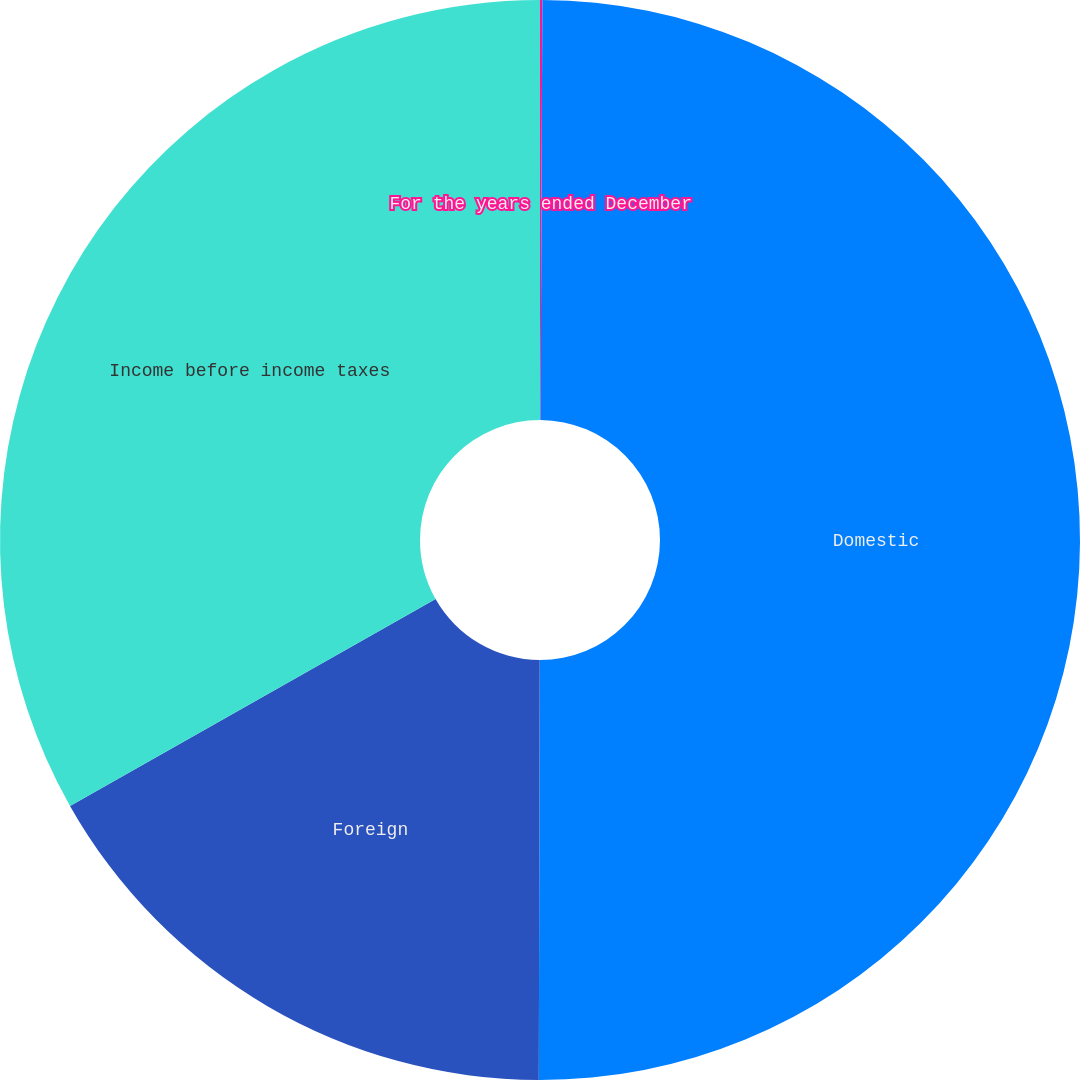Convert chart to OTSL. <chart><loc_0><loc_0><loc_500><loc_500><pie_chart><fcel>For the years ended December<fcel>Domestic<fcel>Foreign<fcel>Income before income taxes<nl><fcel>0.07%<fcel>49.96%<fcel>16.77%<fcel>33.19%<nl></chart> 